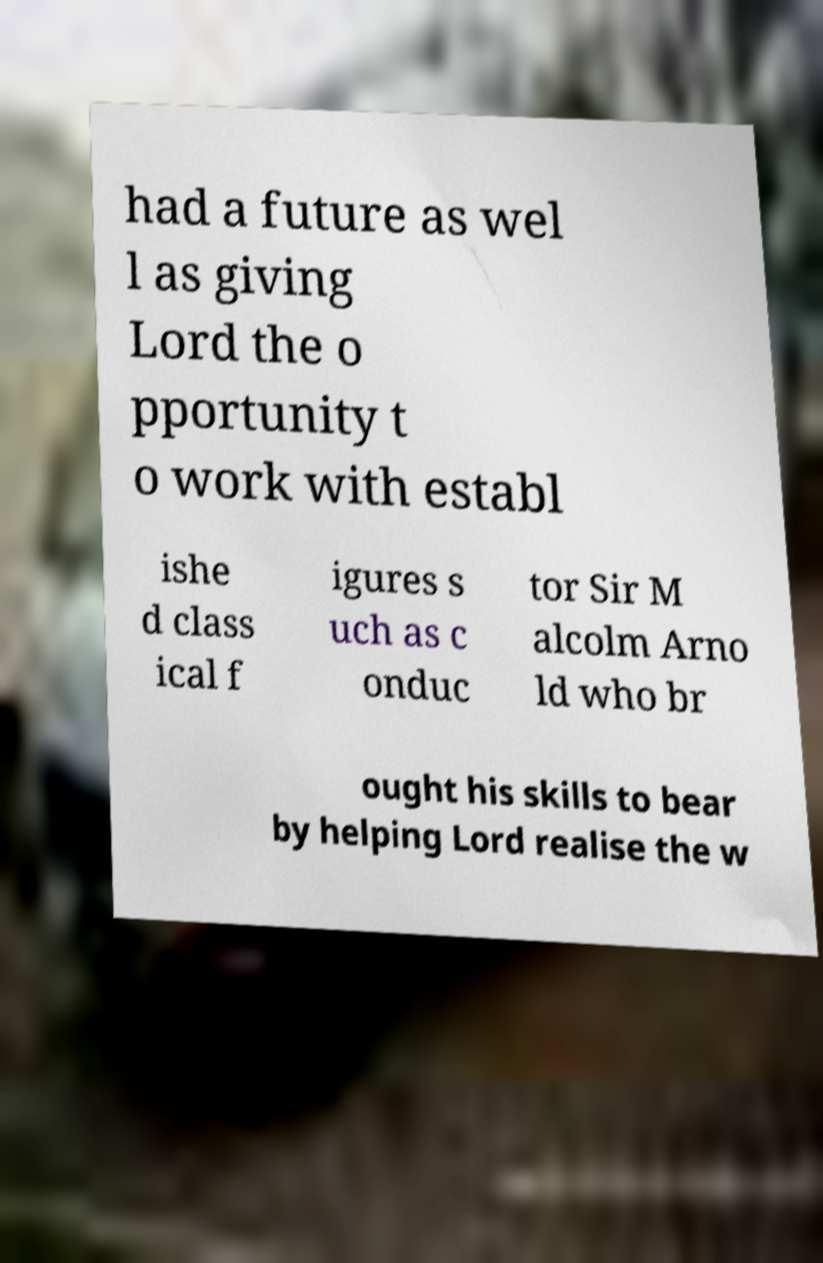There's text embedded in this image that I need extracted. Can you transcribe it verbatim? had a future as wel l as giving Lord the o pportunity t o work with establ ishe d class ical f igures s uch as c onduc tor Sir M alcolm Arno ld who br ought his skills to bear by helping Lord realise the w 